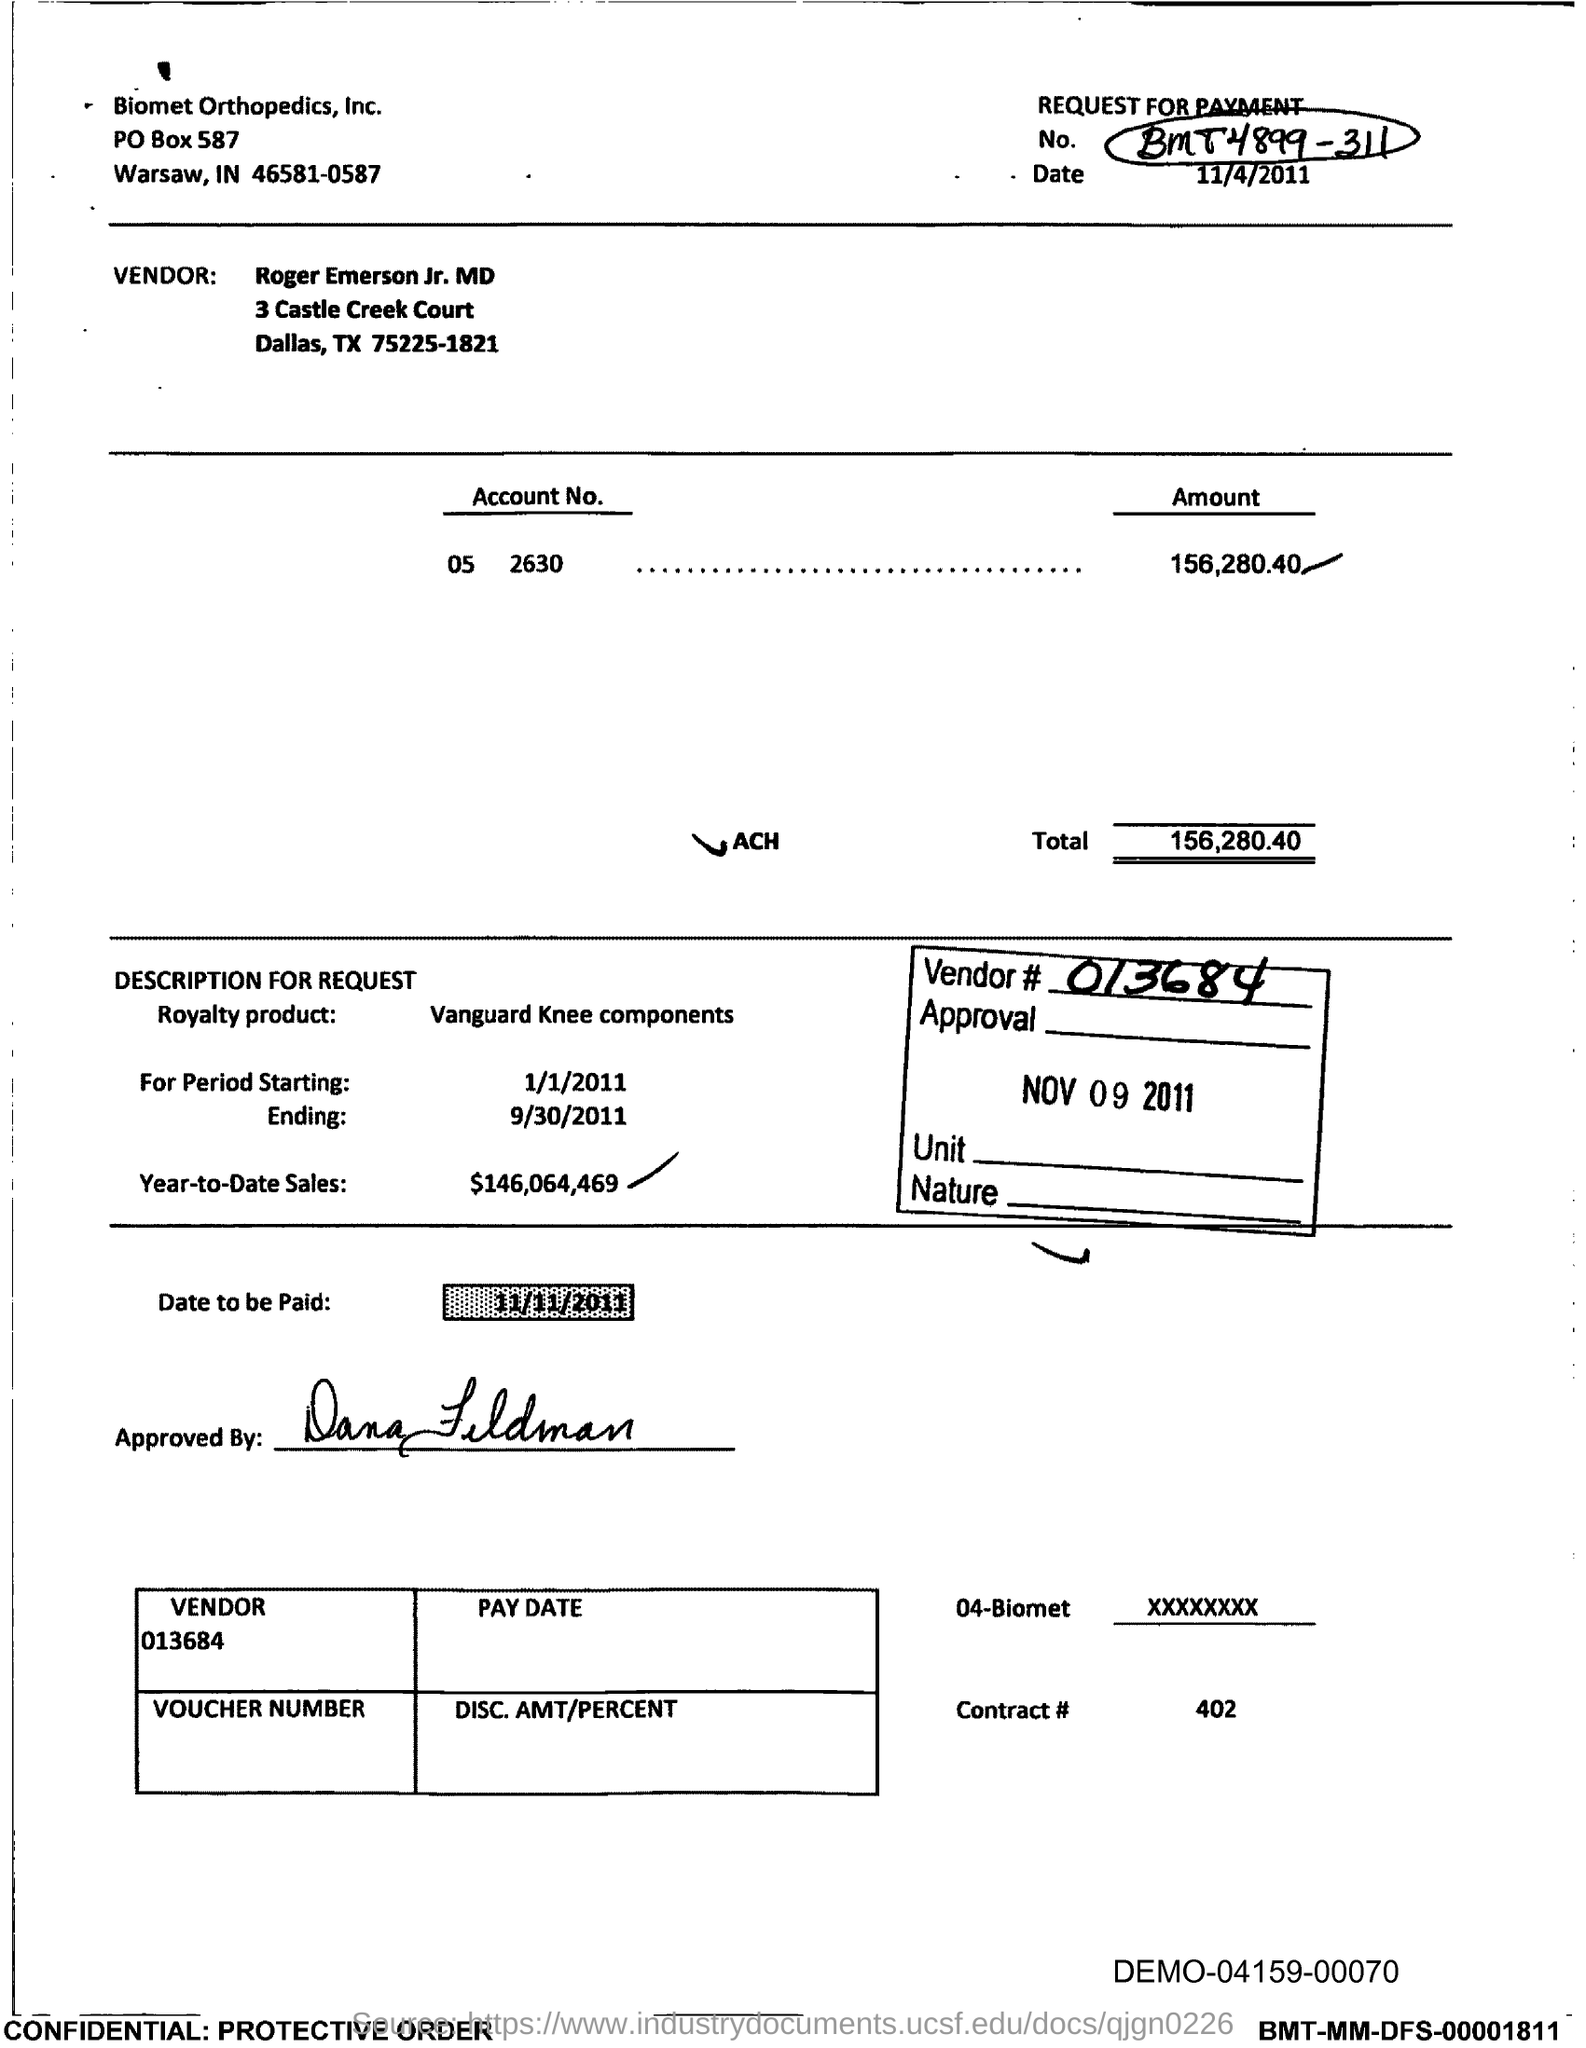What is the Account No. given in the voucher?
Your answer should be compact. 05 2630. What is the total amount mentioned in the voucher?
Your answer should be very brief. 156,280.40. What is the royalty product given in the voucher?
Your answer should be very brief. Vanguard Knee Components. What is the start date of the royalty period?
Give a very brief answer. 1/1/2011. What is the Year-to-Date Sales of the royalty product?
Make the answer very short. $146,064,469. What is the Contract # given in the voucher?
Your answer should be very brief. 402. What is the end date of the royalty period?
Offer a terse response. 9/30/2011. 